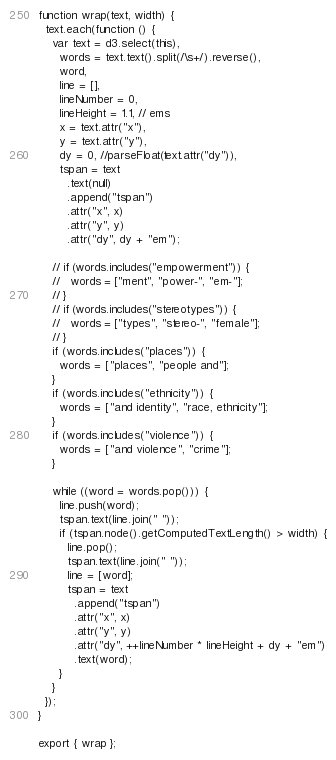Convert code to text. <code><loc_0><loc_0><loc_500><loc_500><_JavaScript_>function wrap(text, width) {
  text.each(function () {
    var text = d3.select(this),
      words = text.text().split(/\s+/).reverse(),
      word,
      line = [],
      lineNumber = 0,
      lineHeight = 1.1, // ems
      x = text.attr("x"),
      y = text.attr("y"),
      dy = 0, //parseFloat(text.attr("dy")),
      tspan = text
        .text(null)
        .append("tspan")
        .attr("x", x)
        .attr("y", y)
        .attr("dy", dy + "em");

    // if (words.includes("empowerment")) {
    //   words = ["ment", "power-", "em-"];
    // }
    // if (words.includes("stereotypes")) {
    //   words = ["types", "stereo-", "female"];
    // }
    if (words.includes("places")) {
      words = ["places", "people and"];
    }
    if (words.includes("ethnicity")) {
      words = ["and identity", "race, ethnicity"];
    }
    if (words.includes("violence")) {
      words = ["and violence", "crime"];
    }

    while ((word = words.pop())) {
      line.push(word);
      tspan.text(line.join(" "));
      if (tspan.node().getComputedTextLength() > width) {
        line.pop();
        tspan.text(line.join(" "));
        line = [word];
        tspan = text
          .append("tspan")
          .attr("x", x)
          .attr("y", y)
          .attr("dy", ++lineNumber * lineHeight + dy + "em")
          .text(word);
      }
    }
  });
}

export { wrap };
</code> 